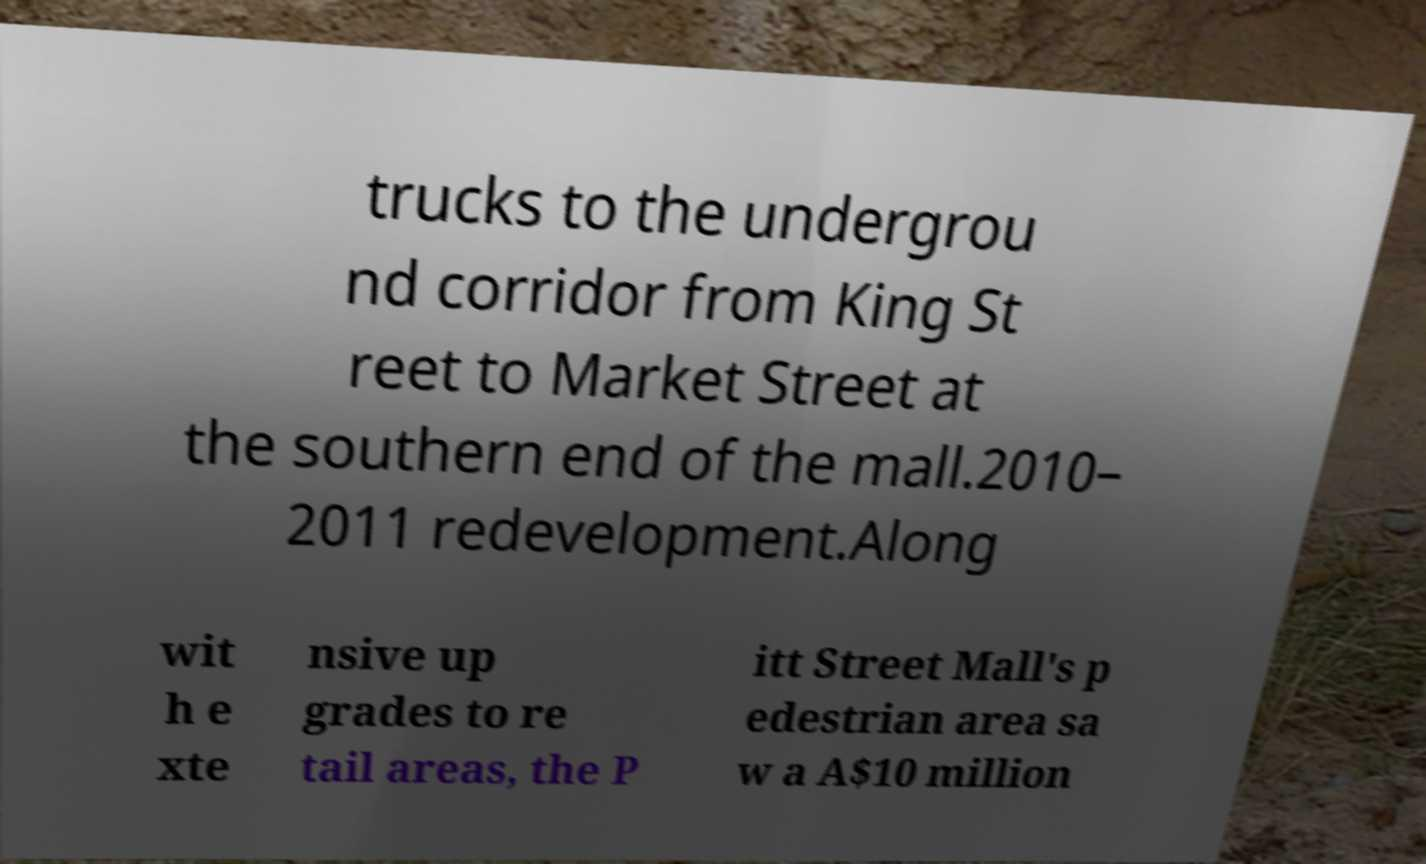I need the written content from this picture converted into text. Can you do that? trucks to the undergrou nd corridor from King St reet to Market Street at the southern end of the mall.2010– 2011 redevelopment.Along wit h e xte nsive up grades to re tail areas, the P itt Street Mall's p edestrian area sa w a A$10 million 